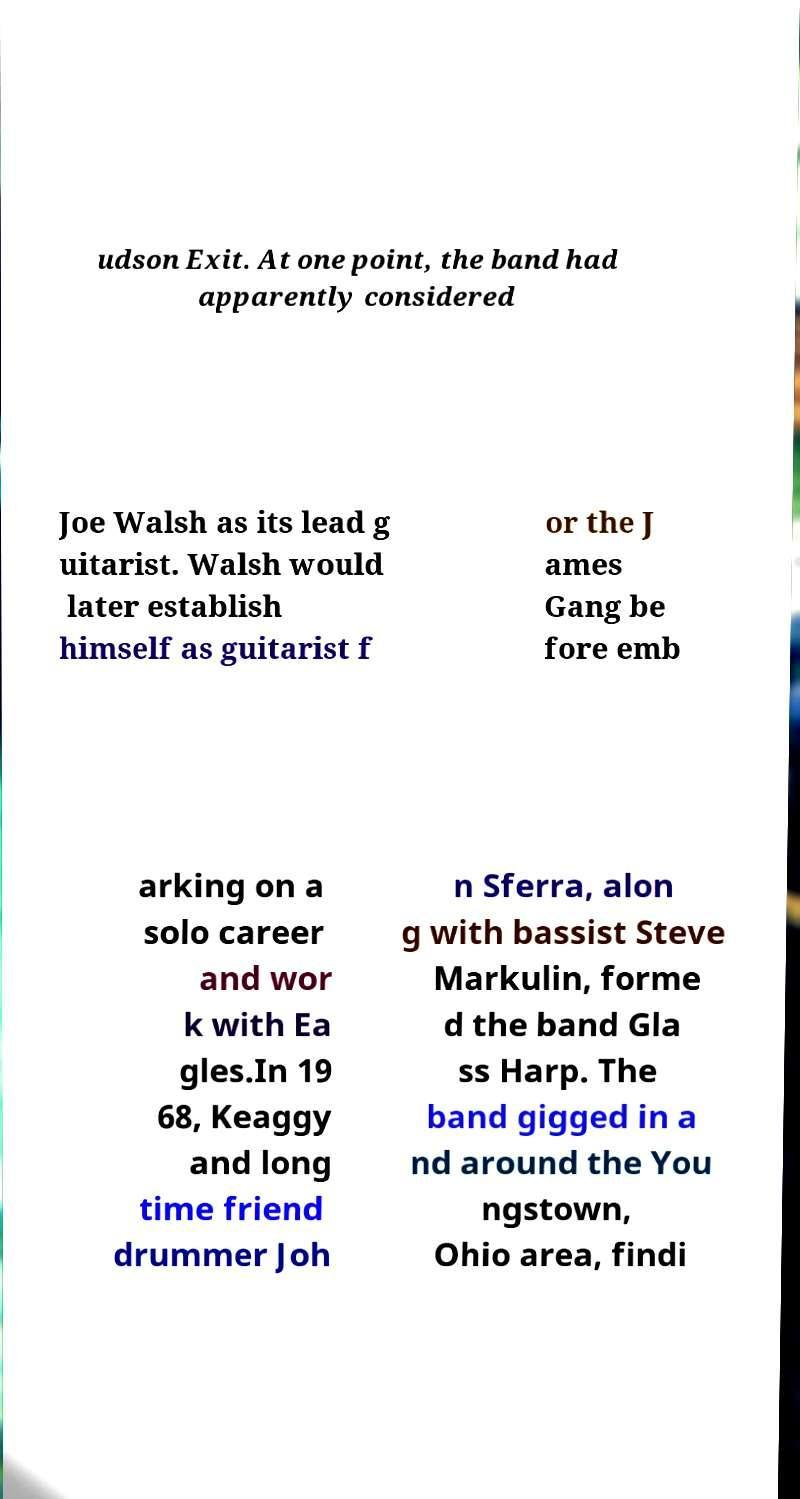Could you extract and type out the text from this image? udson Exit. At one point, the band had apparently considered Joe Walsh as its lead g uitarist. Walsh would later establish himself as guitarist f or the J ames Gang be fore emb arking on a solo career and wor k with Ea gles.In 19 68, Keaggy and long time friend drummer Joh n Sferra, alon g with bassist Steve Markulin, forme d the band Gla ss Harp. The band gigged in a nd around the You ngstown, Ohio area, findi 